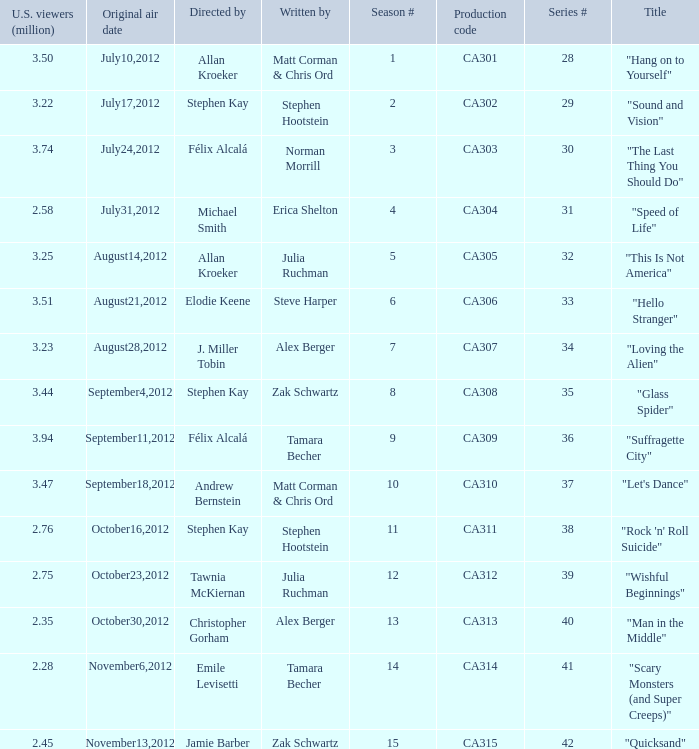Who directed the episode with production code ca311? Stephen Kay. 